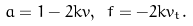<formula> <loc_0><loc_0><loc_500><loc_500>a = 1 - 2 k v , \ f = - 2 k v _ { t } .</formula> 